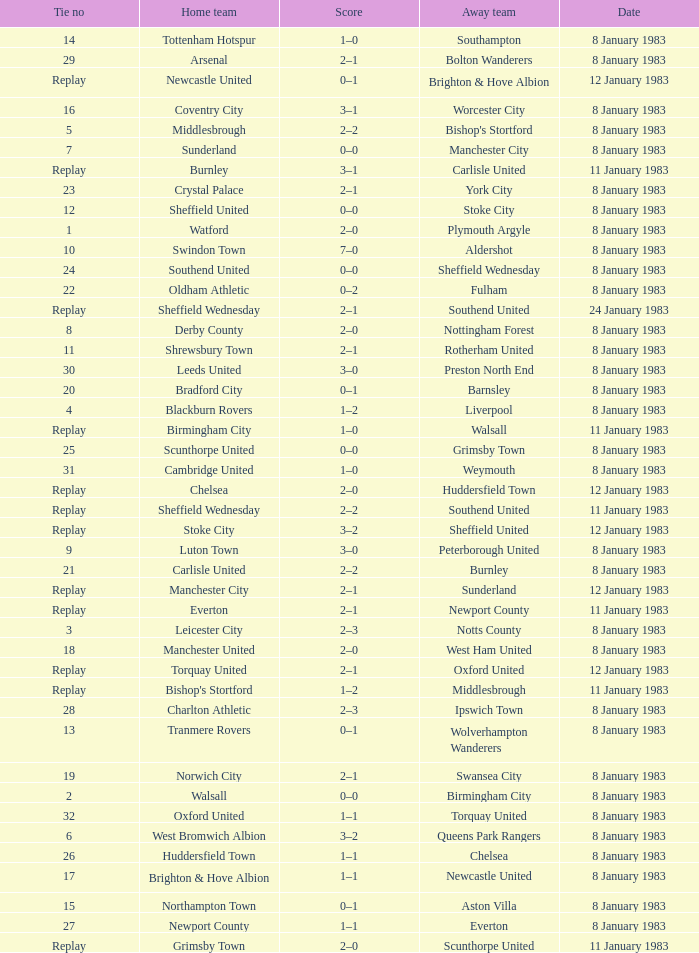In the tie where Southampton was the away team, who was the home team? Tottenham Hotspur. 